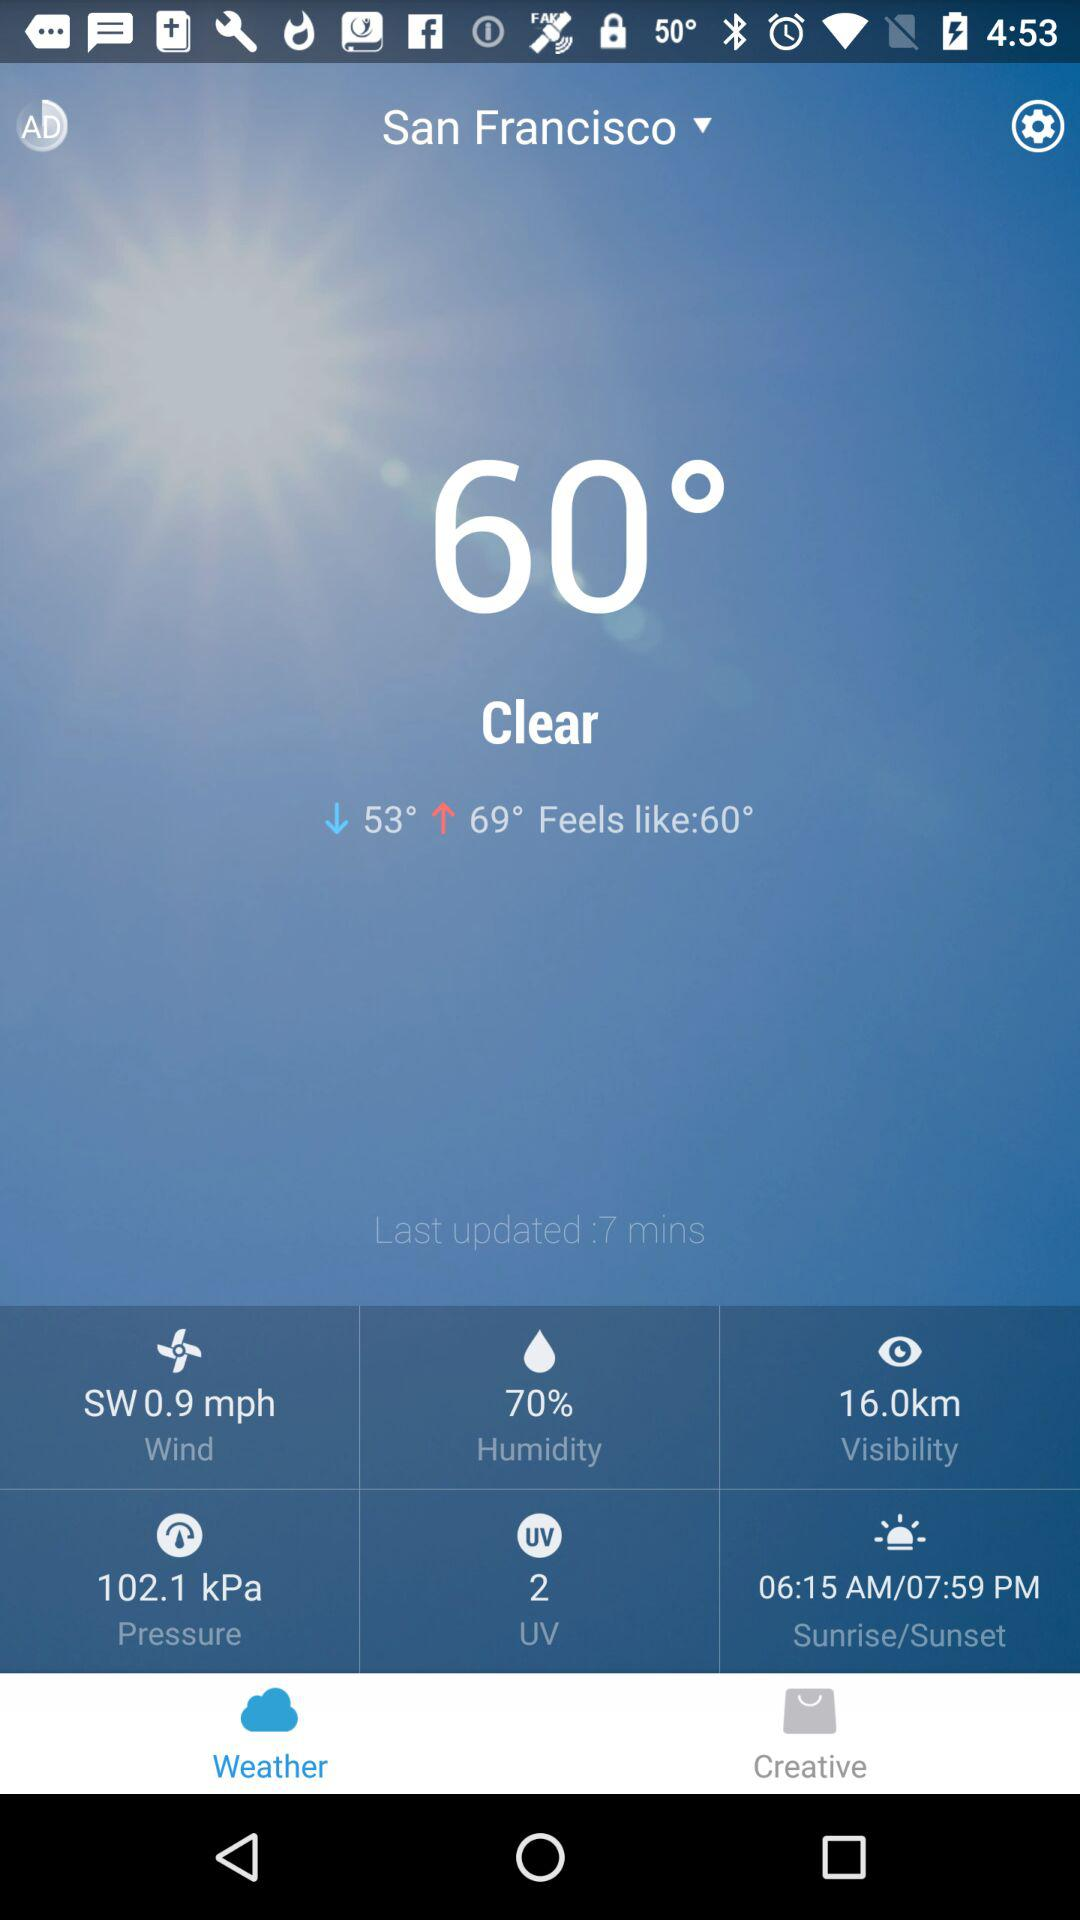What is the humidity percentage?
Answer the question using a single word or phrase. 70% 